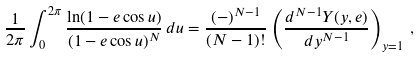Convert formula to latex. <formula><loc_0><loc_0><loc_500><loc_500>\frac { 1 } { 2 \pi } \int _ { 0 } ^ { 2 \pi } \frac { \ln ( 1 - e \cos u ) } { ( 1 - e \cos u ) ^ { N } } \, d u = \frac { ( - ) ^ { N - 1 } } { ( N - 1 ) ! } \left ( \frac { d ^ { N - 1 } Y ( y , e ) } { d y ^ { N - 1 } } \right ) _ { y = 1 } \, ,</formula> 